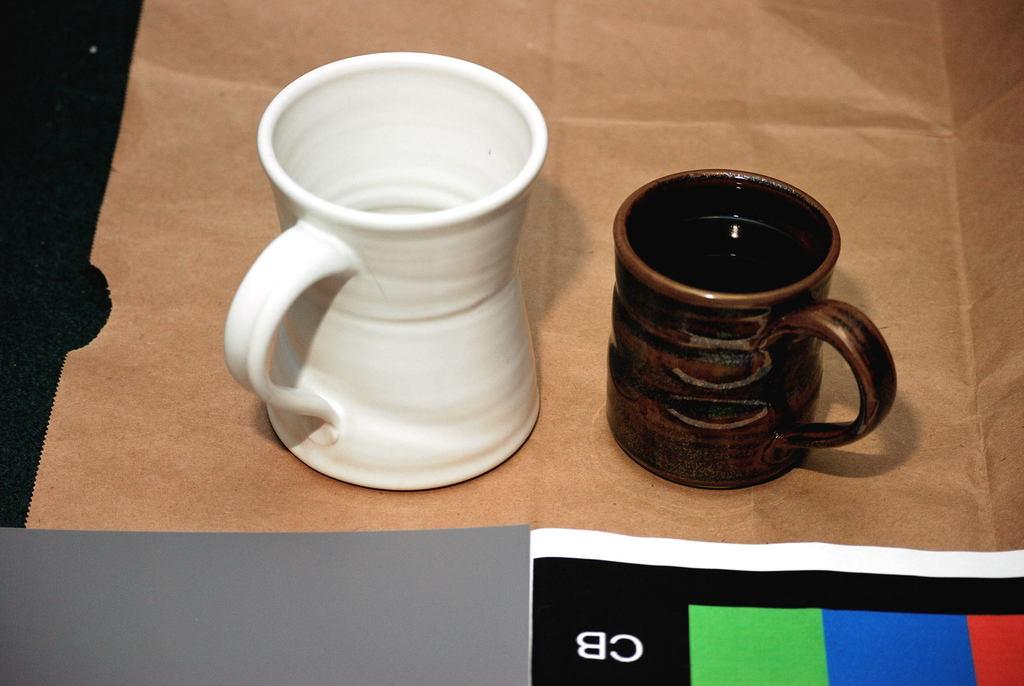Provide a one-sentence caption for the provided image. A white mug and a brown mug sit on a brown paper bag in front of a colorful paper with CB on it. 